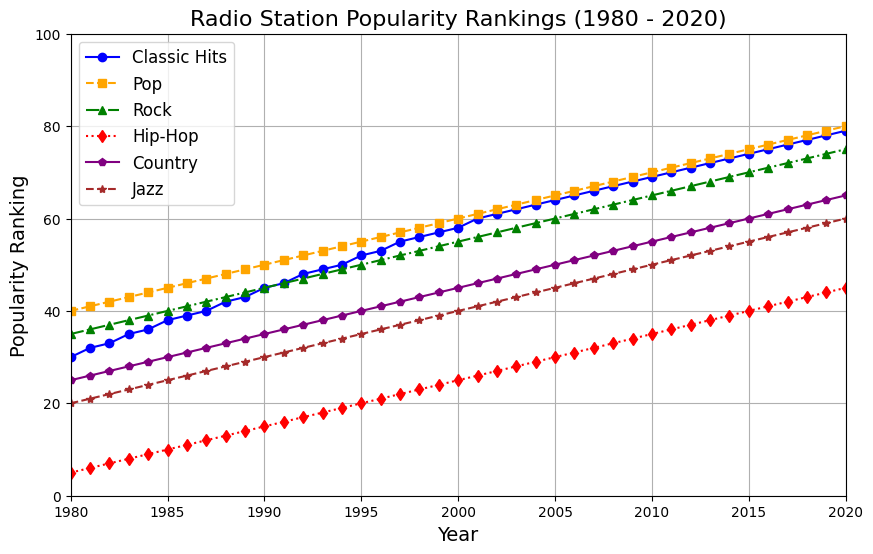What is the rank of Classic Hits in 1980? In 1980, look at the point corresponding to Classic Hits, which is marked in blue. The y-axis value represents the popularity ranking.
Answer: 30 Which genre had the highest popularity ranking in 2000? In 2000, compare the y-axis values for all genres. The genre with the highest value on the y-axis is the one with the highest popularity ranking.
Answer: Pop How much did the popularity ranking of Classic Hits increase from 1980 to 2020? Check the y-axis value of Classic Hits in 1980 (blue line) and 2020. Subtract the 1980 value from the 2020 value.
Answer: 49 Among Classic Hits, Rock, and Jazz, which genre experienced the least growth from 1980 to 2020? Calculate the difference in y-axis values from 1980 to 2020 for Classic Hits (blue), Rock (green), and Jazz (brown). Compare these differences.
Answer: Jazz What was the average popularity ranking of Hip-Hop over the entire 40-year span? Sum up all the y-axis values for Hip-Hop (red line) from 1980 to 2020 and divide by the number of years (41).
Answer: 25 Which year did Classic Hits surpass the popularity ranking of Jazz? Look for the year where the blue line (Classic Hits) crosses above the brown line (Jazz) for the first time.
Answer: 1991 In which year did Country achieve a popularity rank of 50? Identify the year when the purple line (Country) reaches the y-axis value of 50.
Answer: 2005 Which genres have steadily increased their popularity ranking from 1980 to 2020? Identify genres whose lines consistently trend upwards from 1980 to 2020 without any dips.
Answer: All genres In which year did the popularity ranking of Rock and Pop become equal? Find the year where the green line (Rock) intersects with the orange line (Pop).
Answer: They never intersect How does the rate of increase in the popularity ranking of Classic Hits compare with Rock between 1980 and 2020? Calculate the slope (rate of increase) for Classic Hits (blue) and Rock (green) from 1980 to 2020 and compare them. Classic Hits: increase of 49 over 40 years, Rock: increase of 40 over 40 years.
Answer: Classic Hits increased faster 